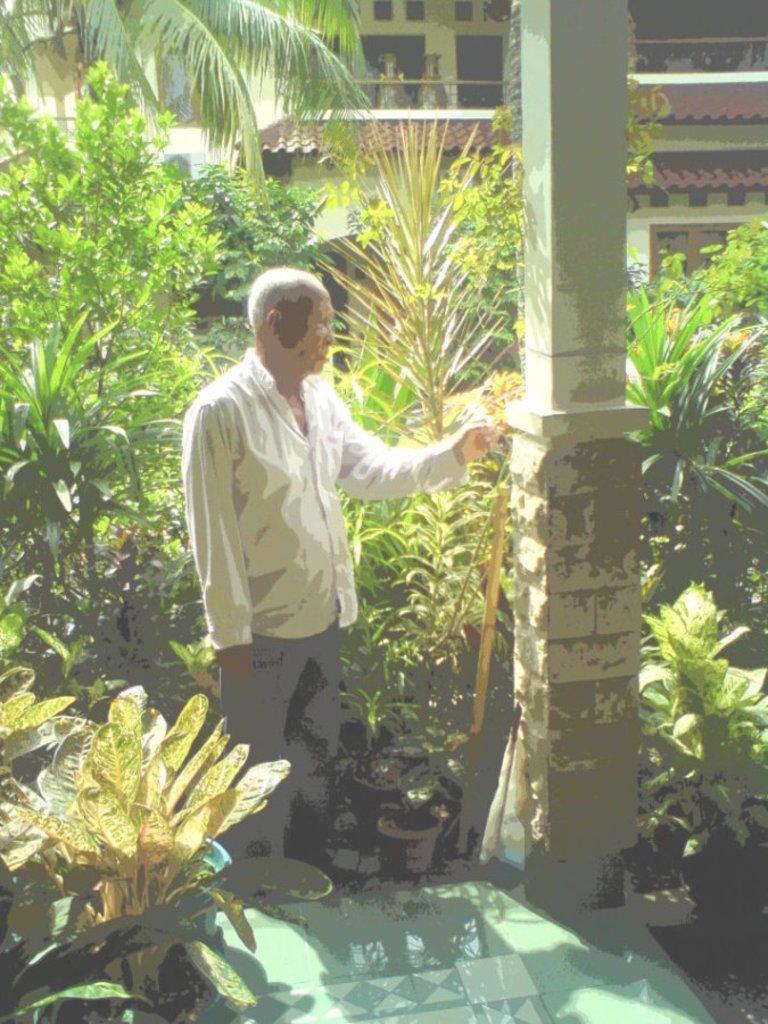Can you describe this image briefly? In this image there is a person standing near a pillar, in the background there are plants and a house. 